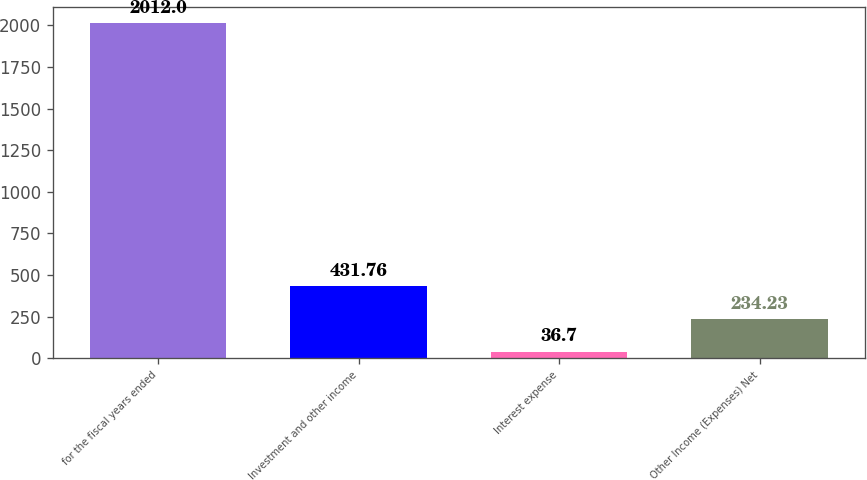Convert chart. <chart><loc_0><loc_0><loc_500><loc_500><bar_chart><fcel>for the fiscal years ended<fcel>Investment and other income<fcel>Interest expense<fcel>Other Income (Expenses) Net<nl><fcel>2012<fcel>431.76<fcel>36.7<fcel>234.23<nl></chart> 